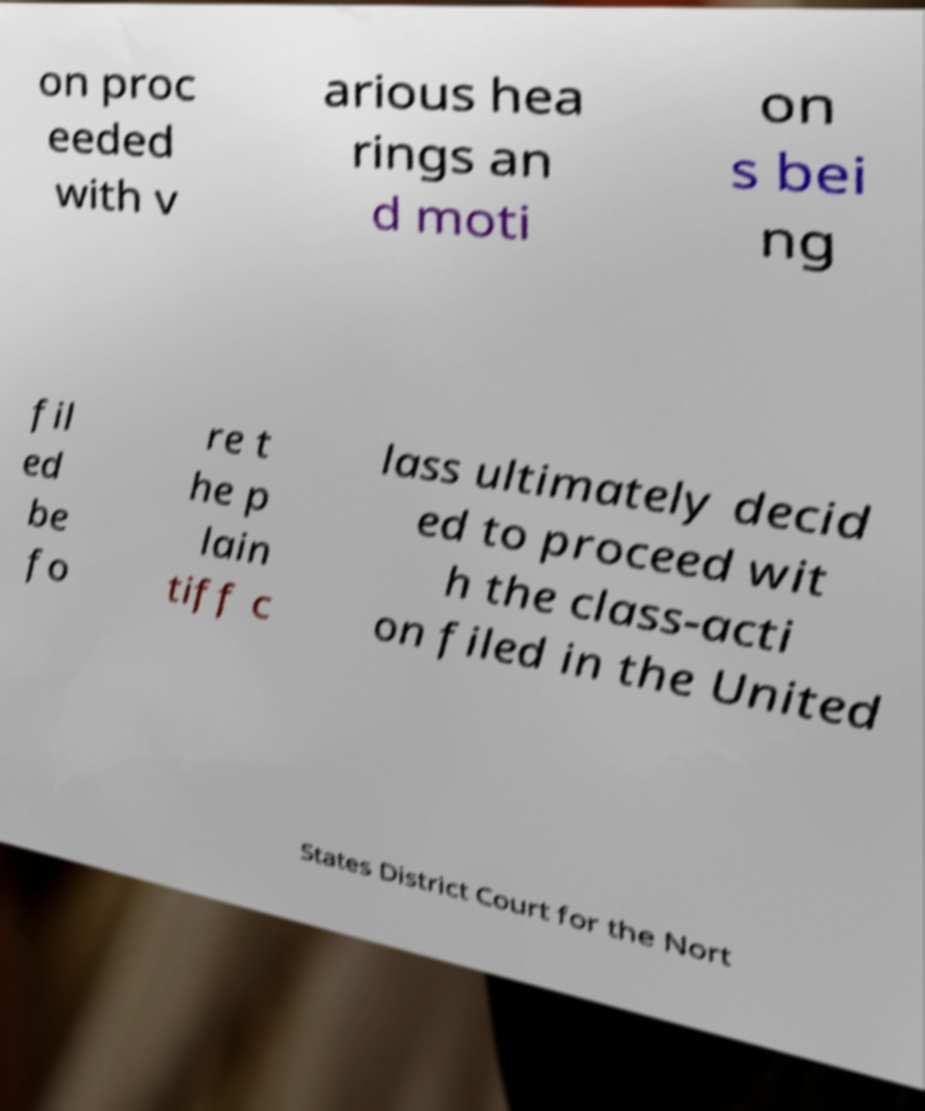For documentation purposes, I need the text within this image transcribed. Could you provide that? on proc eeded with v arious hea rings an d moti on s bei ng fil ed be fo re t he p lain tiff c lass ultimately decid ed to proceed wit h the class-acti on filed in the United States District Court for the Nort 